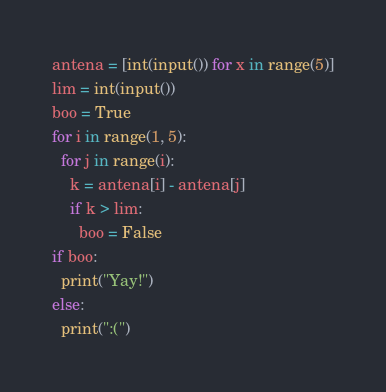Convert code to text. <code><loc_0><loc_0><loc_500><loc_500><_Python_>antena = [int(input()) for x in range(5)]
lim = int(input())
boo = True
for i in range(1, 5):
  for j in range(i):
    k = antena[i] - antena[j]
    if k > lim:
      boo = False
if boo:
  print("Yay!")
else:
  print(":(")</code> 